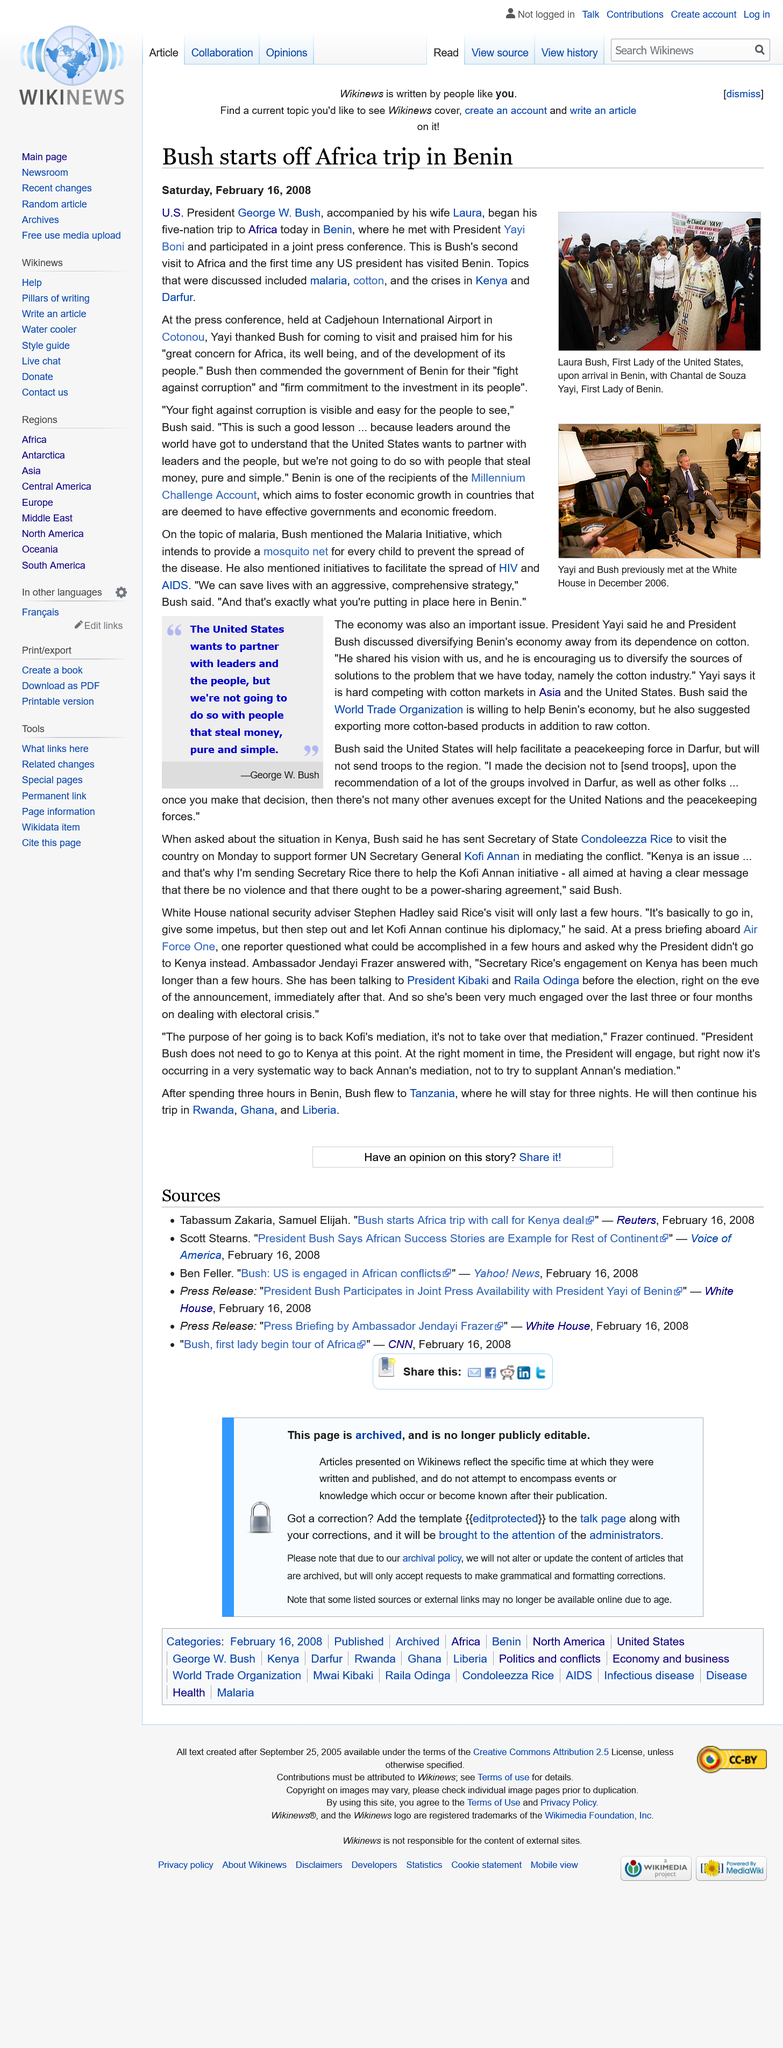Point out several critical features in this image. It is known that George W. Bush's wife is named Laura. Benin is located in the continent of Africa. Cadjehoun International Airport is the name of the airport in Cotonou. 